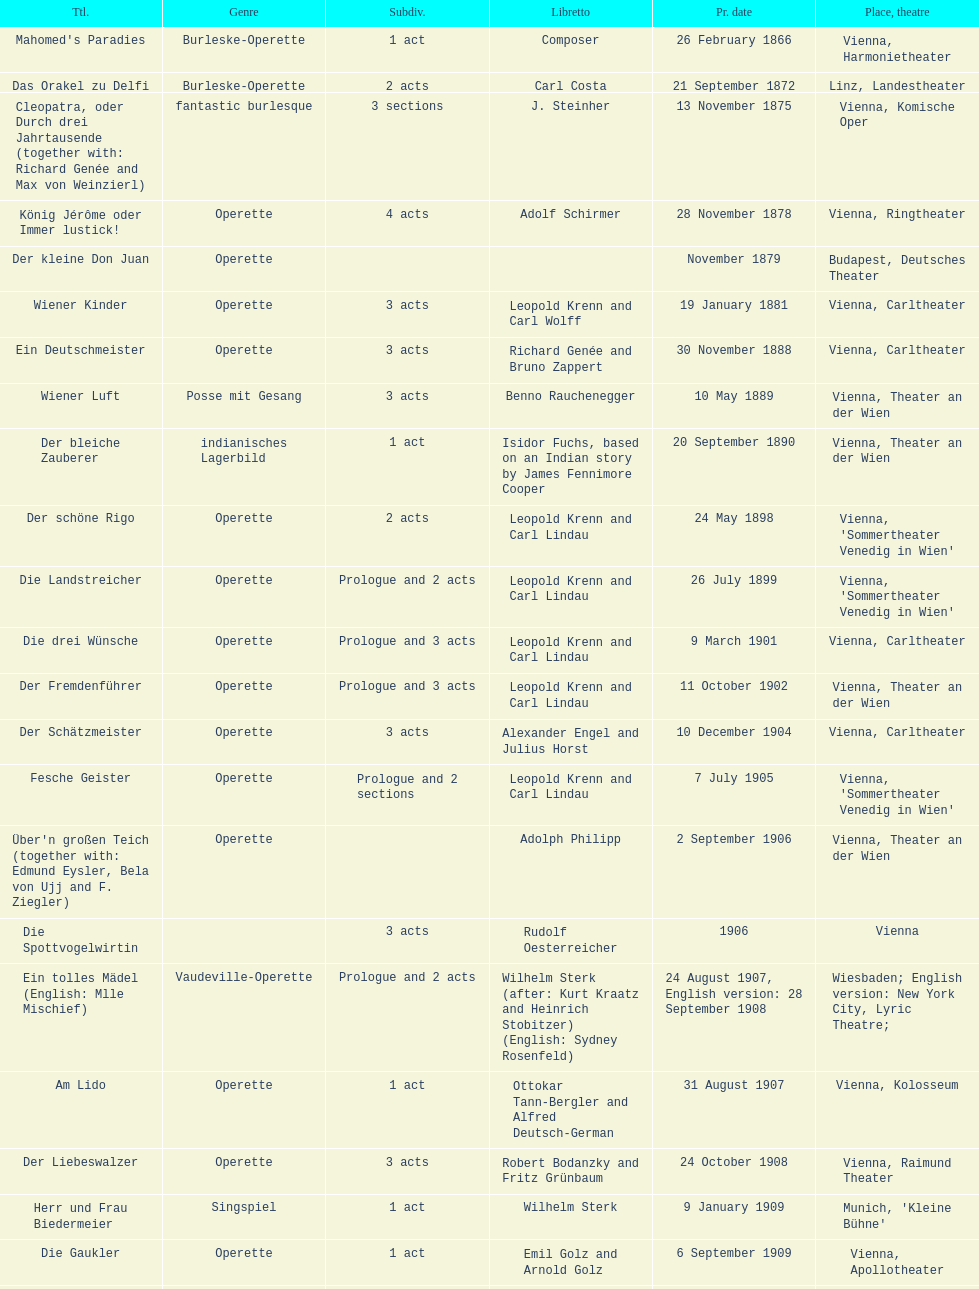All the dates are no later than what year? 1958. 